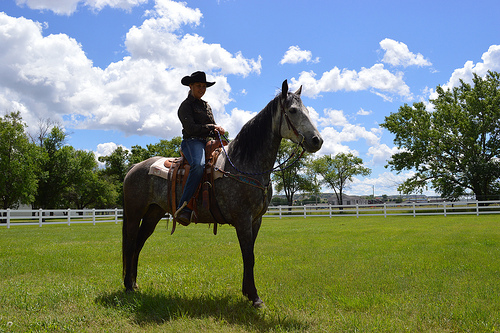<image>
Is there a women on the horse? Yes. Looking at the image, I can see the women is positioned on top of the horse, with the horse providing support. Is the horse in front of the tree? Yes. The horse is positioned in front of the tree, appearing closer to the camera viewpoint. 